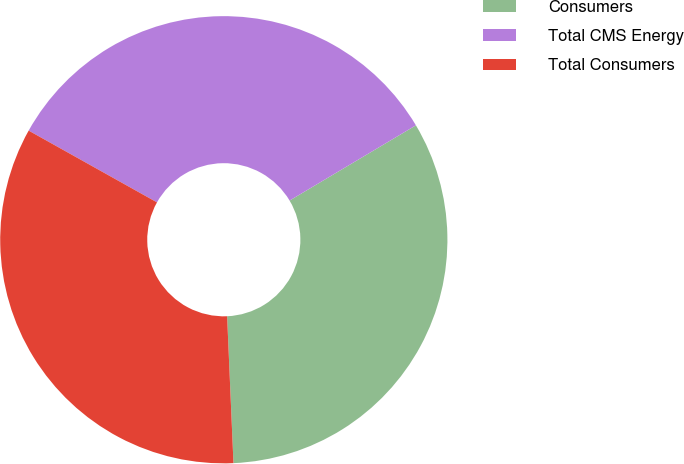Convert chart to OTSL. <chart><loc_0><loc_0><loc_500><loc_500><pie_chart><fcel>Consumers<fcel>Total CMS Energy<fcel>Total Consumers<nl><fcel>32.86%<fcel>33.33%<fcel>33.8%<nl></chart> 